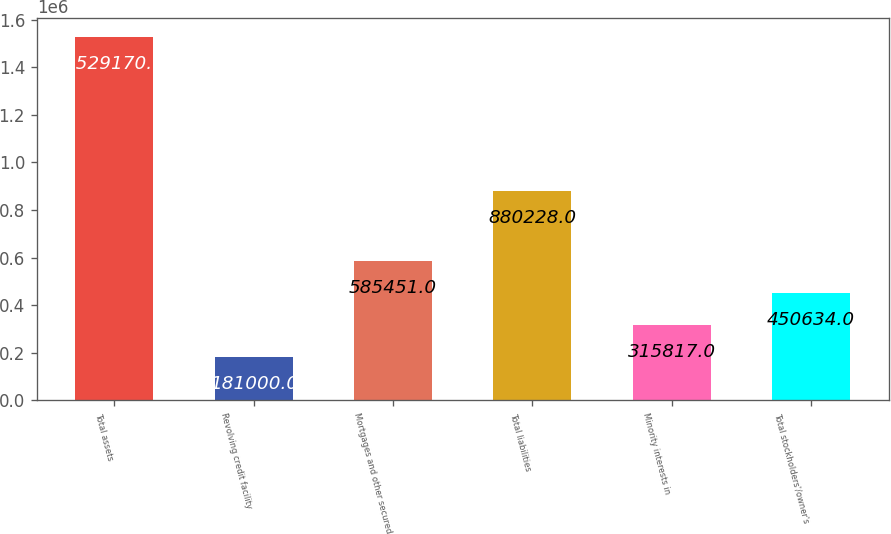<chart> <loc_0><loc_0><loc_500><loc_500><bar_chart><fcel>Total assets<fcel>Revolving credit facility<fcel>Mortgages and other secured<fcel>Total liabilities<fcel>Minority interests in<fcel>Total stockholders'/owner's<nl><fcel>1.52917e+06<fcel>181000<fcel>585451<fcel>880228<fcel>315817<fcel>450634<nl></chart> 